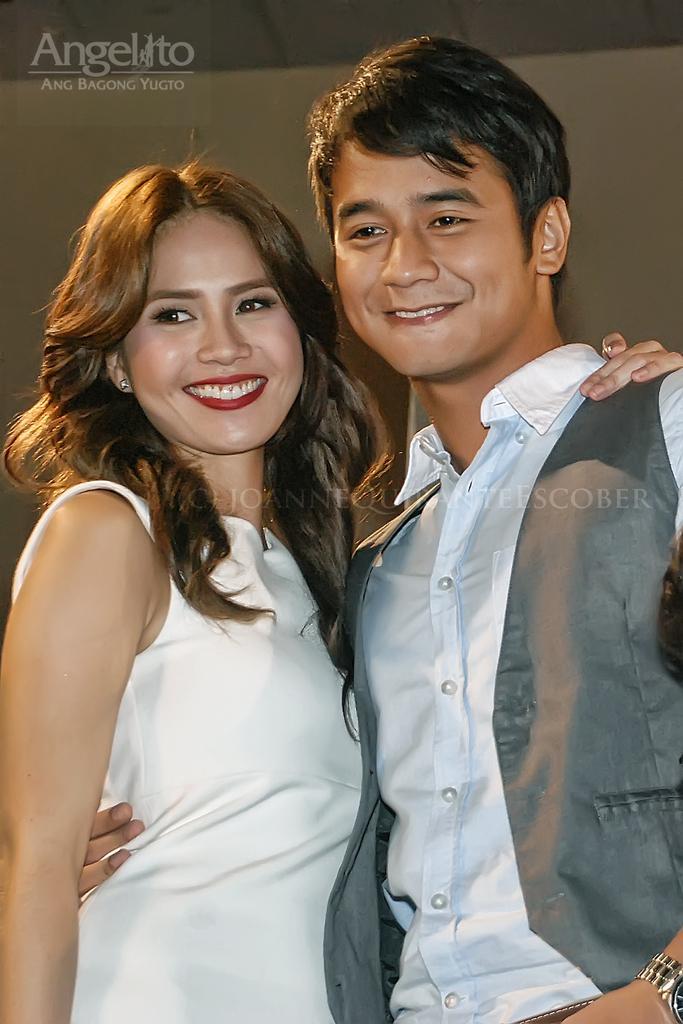Describe this image in one or two sentences. In this image at front there are two persons wearing a smile on their faces. On the backside there is a wall. 